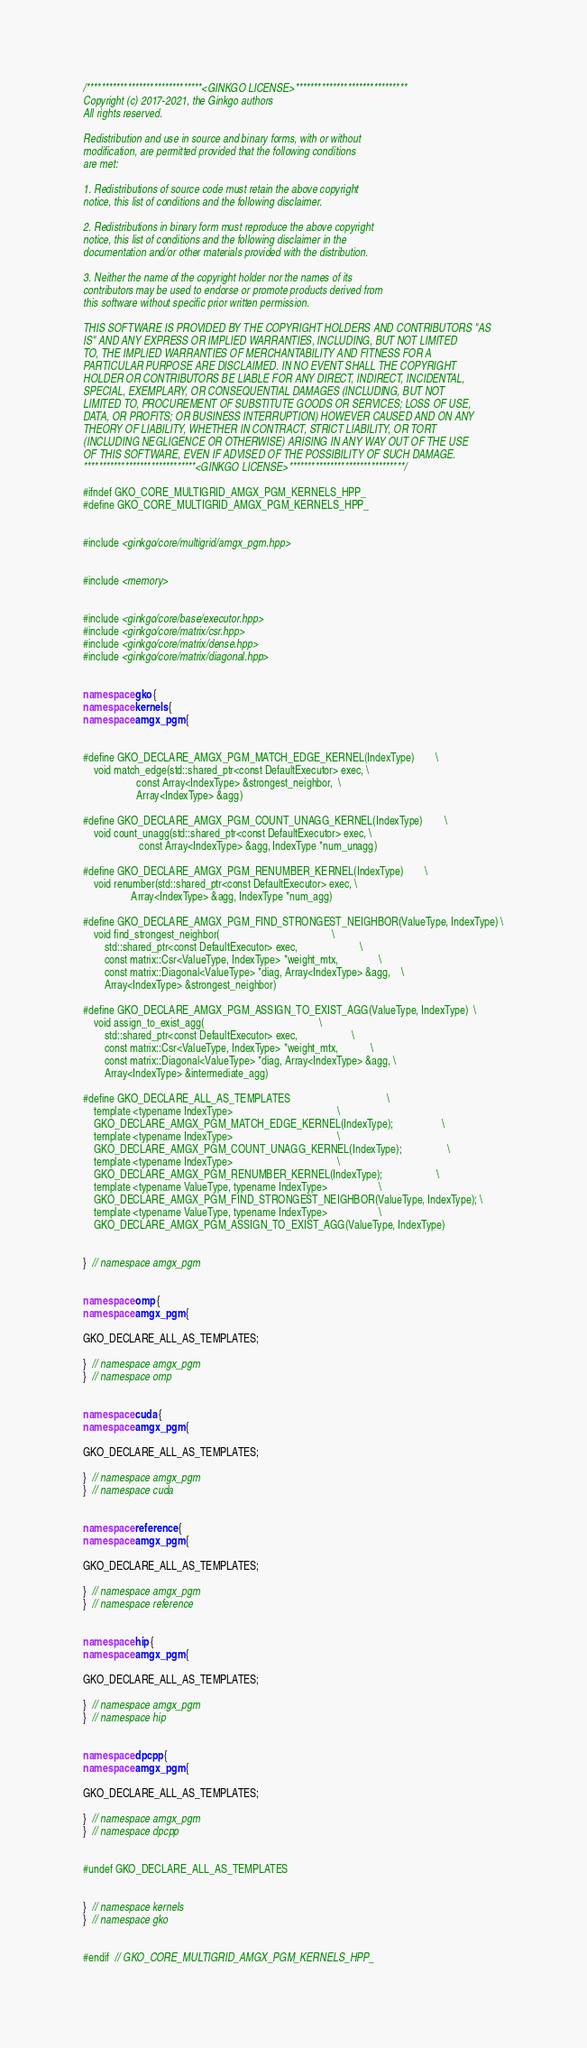Convert code to text. <code><loc_0><loc_0><loc_500><loc_500><_C++_>/*******************************<GINKGO LICENSE>******************************
Copyright (c) 2017-2021, the Ginkgo authors
All rights reserved.

Redistribution and use in source and binary forms, with or without
modification, are permitted provided that the following conditions
are met:

1. Redistributions of source code must retain the above copyright
notice, this list of conditions and the following disclaimer.

2. Redistributions in binary form must reproduce the above copyright
notice, this list of conditions and the following disclaimer in the
documentation and/or other materials provided with the distribution.

3. Neither the name of the copyright holder nor the names of its
contributors may be used to endorse or promote products derived from
this software without specific prior written permission.

THIS SOFTWARE IS PROVIDED BY THE COPYRIGHT HOLDERS AND CONTRIBUTORS "AS
IS" AND ANY EXPRESS OR IMPLIED WARRANTIES, INCLUDING, BUT NOT LIMITED
TO, THE IMPLIED WARRANTIES OF MERCHANTABILITY AND FITNESS FOR A
PARTICULAR PURPOSE ARE DISCLAIMED. IN NO EVENT SHALL THE COPYRIGHT
HOLDER OR CONTRIBUTORS BE LIABLE FOR ANY DIRECT, INDIRECT, INCIDENTAL,
SPECIAL, EXEMPLARY, OR CONSEQUENTIAL DAMAGES (INCLUDING, BUT NOT
LIMITED TO, PROCUREMENT OF SUBSTITUTE GOODS OR SERVICES; LOSS OF USE,
DATA, OR PROFITS; OR BUSINESS INTERRUPTION) HOWEVER CAUSED AND ON ANY
THEORY OF LIABILITY, WHETHER IN CONTRACT, STRICT LIABILITY, OR TORT
(INCLUDING NEGLIGENCE OR OTHERWISE) ARISING IN ANY WAY OUT OF THE USE
OF THIS SOFTWARE, EVEN IF ADVISED OF THE POSSIBILITY OF SUCH DAMAGE.
******************************<GINKGO LICENSE>*******************************/

#ifndef GKO_CORE_MULTIGRID_AMGX_PGM_KERNELS_HPP_
#define GKO_CORE_MULTIGRID_AMGX_PGM_KERNELS_HPP_


#include <ginkgo/core/multigrid/amgx_pgm.hpp>


#include <memory>


#include <ginkgo/core/base/executor.hpp>
#include <ginkgo/core/matrix/csr.hpp>
#include <ginkgo/core/matrix/dense.hpp>
#include <ginkgo/core/matrix/diagonal.hpp>


namespace gko {
namespace kernels {
namespace amgx_pgm {


#define GKO_DECLARE_AMGX_PGM_MATCH_EDGE_KERNEL(IndexType)        \
    void match_edge(std::shared_ptr<const DefaultExecutor> exec, \
                    const Array<IndexType> &strongest_neighbor,  \
                    Array<IndexType> &agg)

#define GKO_DECLARE_AMGX_PGM_COUNT_UNAGG_KERNEL(IndexType)        \
    void count_unagg(std::shared_ptr<const DefaultExecutor> exec, \
                     const Array<IndexType> &agg, IndexType *num_unagg)

#define GKO_DECLARE_AMGX_PGM_RENUMBER_KERNEL(IndexType)        \
    void renumber(std::shared_ptr<const DefaultExecutor> exec, \
                  Array<IndexType> &agg, IndexType *num_agg)

#define GKO_DECLARE_AMGX_PGM_FIND_STRONGEST_NEIGHBOR(ValueType, IndexType) \
    void find_strongest_neighbor(                                          \
        std::shared_ptr<const DefaultExecutor> exec,                       \
        const matrix::Csr<ValueType, IndexType> *weight_mtx,               \
        const matrix::Diagonal<ValueType> *diag, Array<IndexType> &agg,    \
        Array<IndexType> &strongest_neighbor)

#define GKO_DECLARE_AMGX_PGM_ASSIGN_TO_EXIST_AGG(ValueType, IndexType)  \
    void assign_to_exist_agg(                                           \
        std::shared_ptr<const DefaultExecutor> exec,                    \
        const matrix::Csr<ValueType, IndexType> *weight_mtx,            \
        const matrix::Diagonal<ValueType> *diag, Array<IndexType> &agg, \
        Array<IndexType> &intermediate_agg)

#define GKO_DECLARE_ALL_AS_TEMPLATES                                    \
    template <typename IndexType>                                       \
    GKO_DECLARE_AMGX_PGM_MATCH_EDGE_KERNEL(IndexType);                  \
    template <typename IndexType>                                       \
    GKO_DECLARE_AMGX_PGM_COUNT_UNAGG_KERNEL(IndexType);                 \
    template <typename IndexType>                                       \
    GKO_DECLARE_AMGX_PGM_RENUMBER_KERNEL(IndexType);                    \
    template <typename ValueType, typename IndexType>                   \
    GKO_DECLARE_AMGX_PGM_FIND_STRONGEST_NEIGHBOR(ValueType, IndexType); \
    template <typename ValueType, typename IndexType>                   \
    GKO_DECLARE_AMGX_PGM_ASSIGN_TO_EXIST_AGG(ValueType, IndexType)


}  // namespace amgx_pgm


namespace omp {
namespace amgx_pgm {

GKO_DECLARE_ALL_AS_TEMPLATES;

}  // namespace amgx_pgm
}  // namespace omp


namespace cuda {
namespace amgx_pgm {

GKO_DECLARE_ALL_AS_TEMPLATES;

}  // namespace amgx_pgm
}  // namespace cuda


namespace reference {
namespace amgx_pgm {

GKO_DECLARE_ALL_AS_TEMPLATES;

}  // namespace amgx_pgm
}  // namespace reference


namespace hip {
namespace amgx_pgm {

GKO_DECLARE_ALL_AS_TEMPLATES;

}  // namespace amgx_pgm
}  // namespace hip


namespace dpcpp {
namespace amgx_pgm {

GKO_DECLARE_ALL_AS_TEMPLATES;

}  // namespace amgx_pgm
}  // namespace dpcpp


#undef GKO_DECLARE_ALL_AS_TEMPLATES


}  // namespace kernels
}  // namespace gko


#endif  // GKO_CORE_MULTIGRID_AMGX_PGM_KERNELS_HPP_
</code> 